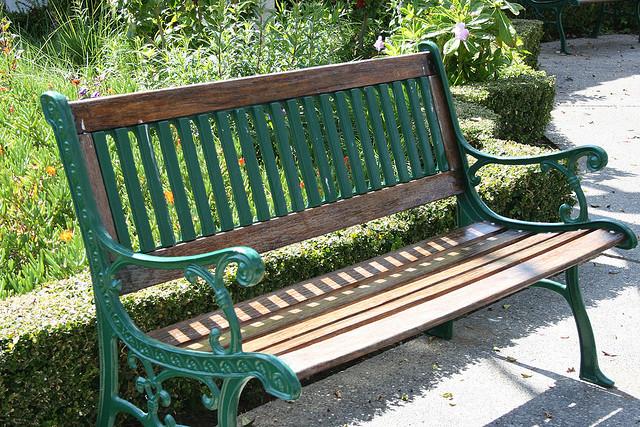Is it a sunny day?
Write a very short answer. Yes. Is this bench partly made of wood?
Be succinct. Yes. Where is this bench?
Concise answer only. Park. 